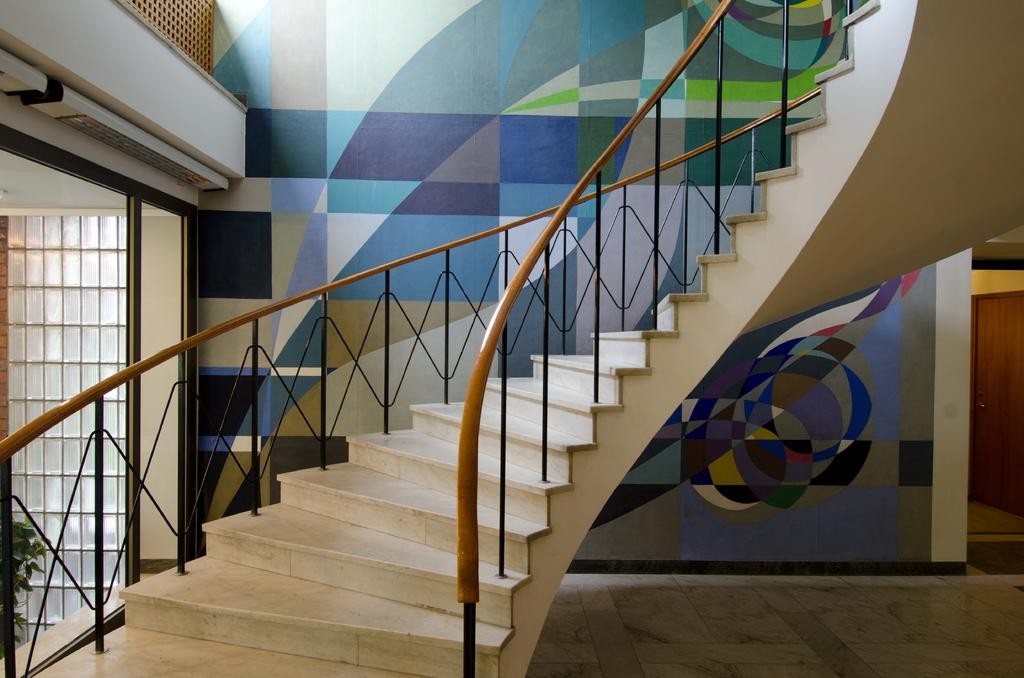Where was the image taken? The image was taken inside a building. What can be seen in the center of the image? There are stairs in the center of the image. What is visible in the background of the image? There is a wall visible in the background of the image. What word is written on the creature's forehead in the image? There is no creature present in the image, so there is no word written on its forehead. 